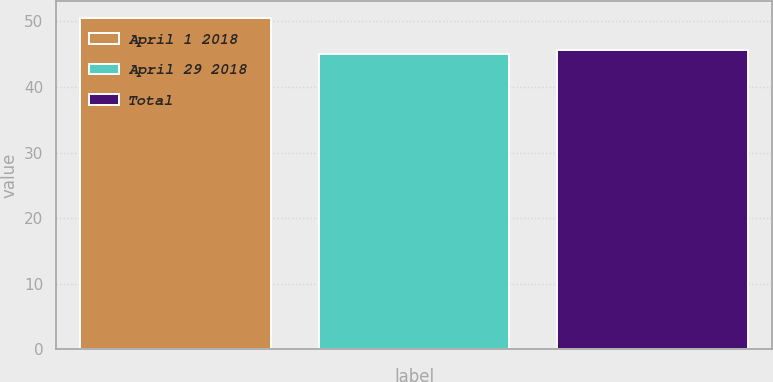Convert chart. <chart><loc_0><loc_0><loc_500><loc_500><bar_chart><fcel>April 1 2018<fcel>April 29 2018<fcel>Total<nl><fcel>50.57<fcel>45.06<fcel>45.61<nl></chart> 